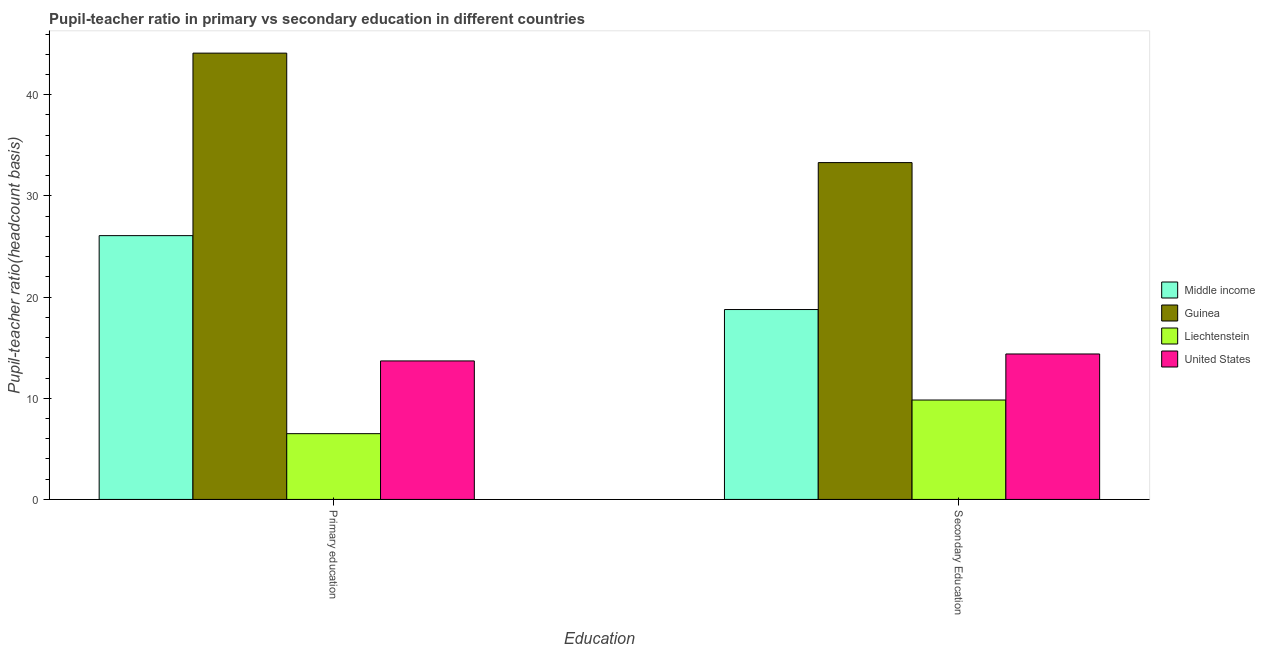How many different coloured bars are there?
Your response must be concise. 4. How many groups of bars are there?
Offer a terse response. 2. Are the number of bars per tick equal to the number of legend labels?
Offer a terse response. Yes. What is the label of the 2nd group of bars from the left?
Your response must be concise. Secondary Education. What is the pupil teacher ratio on secondary education in United States?
Offer a terse response. 14.38. Across all countries, what is the maximum pupil-teacher ratio in primary education?
Your answer should be compact. 44.11. Across all countries, what is the minimum pupil-teacher ratio in primary education?
Offer a terse response. 6.5. In which country was the pupil-teacher ratio in primary education maximum?
Make the answer very short. Guinea. In which country was the pupil-teacher ratio in primary education minimum?
Your answer should be very brief. Liechtenstein. What is the total pupil teacher ratio on secondary education in the graph?
Offer a very short reply. 76.26. What is the difference between the pupil-teacher ratio in primary education in Middle income and that in Liechtenstein?
Provide a succinct answer. 19.57. What is the difference between the pupil teacher ratio on secondary education in United States and the pupil-teacher ratio in primary education in Liechtenstein?
Your answer should be very brief. 7.88. What is the average pupil-teacher ratio in primary education per country?
Offer a very short reply. 22.59. What is the difference between the pupil teacher ratio on secondary education and pupil-teacher ratio in primary education in United States?
Provide a short and direct response. 0.69. In how many countries, is the pupil teacher ratio on secondary education greater than 38 ?
Your answer should be very brief. 0. What is the ratio of the pupil teacher ratio on secondary education in Middle income to that in United States?
Make the answer very short. 1.31. What does the 2nd bar from the right in Secondary Education represents?
Make the answer very short. Liechtenstein. How many bars are there?
Provide a short and direct response. 8. Are all the bars in the graph horizontal?
Offer a very short reply. No. What is the difference between two consecutive major ticks on the Y-axis?
Keep it short and to the point. 10. How many legend labels are there?
Your answer should be very brief. 4. What is the title of the graph?
Give a very brief answer. Pupil-teacher ratio in primary vs secondary education in different countries. What is the label or title of the X-axis?
Offer a very short reply. Education. What is the label or title of the Y-axis?
Provide a short and direct response. Pupil-teacher ratio(headcount basis). What is the Pupil-teacher ratio(headcount basis) of Middle income in Primary education?
Make the answer very short. 26.07. What is the Pupil-teacher ratio(headcount basis) of Guinea in Primary education?
Offer a terse response. 44.11. What is the Pupil-teacher ratio(headcount basis) in United States in Primary education?
Provide a succinct answer. 13.69. What is the Pupil-teacher ratio(headcount basis) in Middle income in Secondary Education?
Provide a short and direct response. 18.77. What is the Pupil-teacher ratio(headcount basis) in Guinea in Secondary Education?
Provide a succinct answer. 33.29. What is the Pupil-teacher ratio(headcount basis) of Liechtenstein in Secondary Education?
Make the answer very short. 9.83. What is the Pupil-teacher ratio(headcount basis) in United States in Secondary Education?
Offer a very short reply. 14.38. Across all Education, what is the maximum Pupil-teacher ratio(headcount basis) in Middle income?
Your response must be concise. 26.07. Across all Education, what is the maximum Pupil-teacher ratio(headcount basis) of Guinea?
Make the answer very short. 44.11. Across all Education, what is the maximum Pupil-teacher ratio(headcount basis) in Liechtenstein?
Your answer should be very brief. 9.83. Across all Education, what is the maximum Pupil-teacher ratio(headcount basis) of United States?
Give a very brief answer. 14.38. Across all Education, what is the minimum Pupil-teacher ratio(headcount basis) of Middle income?
Offer a very short reply. 18.77. Across all Education, what is the minimum Pupil-teacher ratio(headcount basis) of Guinea?
Keep it short and to the point. 33.29. Across all Education, what is the minimum Pupil-teacher ratio(headcount basis) of United States?
Offer a terse response. 13.69. What is the total Pupil-teacher ratio(headcount basis) in Middle income in the graph?
Your response must be concise. 44.84. What is the total Pupil-teacher ratio(headcount basis) of Guinea in the graph?
Offer a very short reply. 77.4. What is the total Pupil-teacher ratio(headcount basis) of Liechtenstein in the graph?
Make the answer very short. 16.33. What is the total Pupil-teacher ratio(headcount basis) of United States in the graph?
Offer a very short reply. 28.07. What is the difference between the Pupil-teacher ratio(headcount basis) in Middle income in Primary education and that in Secondary Education?
Offer a very short reply. 7.31. What is the difference between the Pupil-teacher ratio(headcount basis) in Guinea in Primary education and that in Secondary Education?
Give a very brief answer. 10.82. What is the difference between the Pupil-teacher ratio(headcount basis) of Liechtenstein in Primary education and that in Secondary Education?
Your answer should be very brief. -3.33. What is the difference between the Pupil-teacher ratio(headcount basis) of United States in Primary education and that in Secondary Education?
Offer a terse response. -0.69. What is the difference between the Pupil-teacher ratio(headcount basis) of Middle income in Primary education and the Pupil-teacher ratio(headcount basis) of Guinea in Secondary Education?
Offer a terse response. -7.22. What is the difference between the Pupil-teacher ratio(headcount basis) of Middle income in Primary education and the Pupil-teacher ratio(headcount basis) of Liechtenstein in Secondary Education?
Your answer should be very brief. 16.25. What is the difference between the Pupil-teacher ratio(headcount basis) of Middle income in Primary education and the Pupil-teacher ratio(headcount basis) of United States in Secondary Education?
Your answer should be very brief. 11.7. What is the difference between the Pupil-teacher ratio(headcount basis) in Guinea in Primary education and the Pupil-teacher ratio(headcount basis) in Liechtenstein in Secondary Education?
Provide a short and direct response. 34.29. What is the difference between the Pupil-teacher ratio(headcount basis) of Guinea in Primary education and the Pupil-teacher ratio(headcount basis) of United States in Secondary Education?
Offer a terse response. 29.73. What is the difference between the Pupil-teacher ratio(headcount basis) in Liechtenstein in Primary education and the Pupil-teacher ratio(headcount basis) in United States in Secondary Education?
Keep it short and to the point. -7.88. What is the average Pupil-teacher ratio(headcount basis) of Middle income per Education?
Provide a short and direct response. 22.42. What is the average Pupil-teacher ratio(headcount basis) of Guinea per Education?
Make the answer very short. 38.7. What is the average Pupil-teacher ratio(headcount basis) of Liechtenstein per Education?
Your response must be concise. 8.16. What is the average Pupil-teacher ratio(headcount basis) of United States per Education?
Provide a short and direct response. 14.03. What is the difference between the Pupil-teacher ratio(headcount basis) in Middle income and Pupil-teacher ratio(headcount basis) in Guinea in Primary education?
Your response must be concise. -18.04. What is the difference between the Pupil-teacher ratio(headcount basis) of Middle income and Pupil-teacher ratio(headcount basis) of Liechtenstein in Primary education?
Provide a short and direct response. 19.57. What is the difference between the Pupil-teacher ratio(headcount basis) of Middle income and Pupil-teacher ratio(headcount basis) of United States in Primary education?
Your answer should be very brief. 12.38. What is the difference between the Pupil-teacher ratio(headcount basis) of Guinea and Pupil-teacher ratio(headcount basis) of Liechtenstein in Primary education?
Provide a succinct answer. 37.61. What is the difference between the Pupil-teacher ratio(headcount basis) in Guinea and Pupil-teacher ratio(headcount basis) in United States in Primary education?
Offer a terse response. 30.42. What is the difference between the Pupil-teacher ratio(headcount basis) of Liechtenstein and Pupil-teacher ratio(headcount basis) of United States in Primary education?
Your response must be concise. -7.19. What is the difference between the Pupil-teacher ratio(headcount basis) in Middle income and Pupil-teacher ratio(headcount basis) in Guinea in Secondary Education?
Your answer should be very brief. -14.52. What is the difference between the Pupil-teacher ratio(headcount basis) of Middle income and Pupil-teacher ratio(headcount basis) of Liechtenstein in Secondary Education?
Give a very brief answer. 8.94. What is the difference between the Pupil-teacher ratio(headcount basis) in Middle income and Pupil-teacher ratio(headcount basis) in United States in Secondary Education?
Your response must be concise. 4.39. What is the difference between the Pupil-teacher ratio(headcount basis) in Guinea and Pupil-teacher ratio(headcount basis) in Liechtenstein in Secondary Education?
Make the answer very short. 23.47. What is the difference between the Pupil-teacher ratio(headcount basis) in Guinea and Pupil-teacher ratio(headcount basis) in United States in Secondary Education?
Your answer should be very brief. 18.92. What is the difference between the Pupil-teacher ratio(headcount basis) in Liechtenstein and Pupil-teacher ratio(headcount basis) in United States in Secondary Education?
Ensure brevity in your answer.  -4.55. What is the ratio of the Pupil-teacher ratio(headcount basis) in Middle income in Primary education to that in Secondary Education?
Offer a terse response. 1.39. What is the ratio of the Pupil-teacher ratio(headcount basis) in Guinea in Primary education to that in Secondary Education?
Offer a terse response. 1.32. What is the ratio of the Pupil-teacher ratio(headcount basis) of Liechtenstein in Primary education to that in Secondary Education?
Provide a short and direct response. 0.66. What is the ratio of the Pupil-teacher ratio(headcount basis) in United States in Primary education to that in Secondary Education?
Make the answer very short. 0.95. What is the difference between the highest and the second highest Pupil-teacher ratio(headcount basis) in Middle income?
Your response must be concise. 7.31. What is the difference between the highest and the second highest Pupil-teacher ratio(headcount basis) in Guinea?
Ensure brevity in your answer.  10.82. What is the difference between the highest and the second highest Pupil-teacher ratio(headcount basis) in Liechtenstein?
Your response must be concise. 3.33. What is the difference between the highest and the second highest Pupil-teacher ratio(headcount basis) in United States?
Give a very brief answer. 0.69. What is the difference between the highest and the lowest Pupil-teacher ratio(headcount basis) of Middle income?
Provide a short and direct response. 7.31. What is the difference between the highest and the lowest Pupil-teacher ratio(headcount basis) in Guinea?
Keep it short and to the point. 10.82. What is the difference between the highest and the lowest Pupil-teacher ratio(headcount basis) of Liechtenstein?
Keep it short and to the point. 3.33. What is the difference between the highest and the lowest Pupil-teacher ratio(headcount basis) in United States?
Offer a terse response. 0.69. 